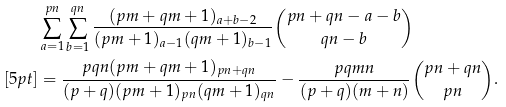<formula> <loc_0><loc_0><loc_500><loc_500>& \sum _ { a = 1 } ^ { p n } \sum _ { b = 1 } ^ { q n } \frac { ( p m + q m + 1 ) _ { a + b - 2 } } { ( p m + 1 ) _ { a - 1 } ( q m + 1 ) _ { b - 1 } } { p n + q n - a - b \choose q n - b } \\ [ 5 p t ] & = \frac { p q n ( p m + q m + 1 ) _ { p n + q n } } { ( p + q ) ( p m + 1 ) _ { p n } ( q m + 1 ) _ { q n } } - \frac { p q m n } { ( p + q ) ( m + n ) } { p n + q n \choose p n } .</formula> 